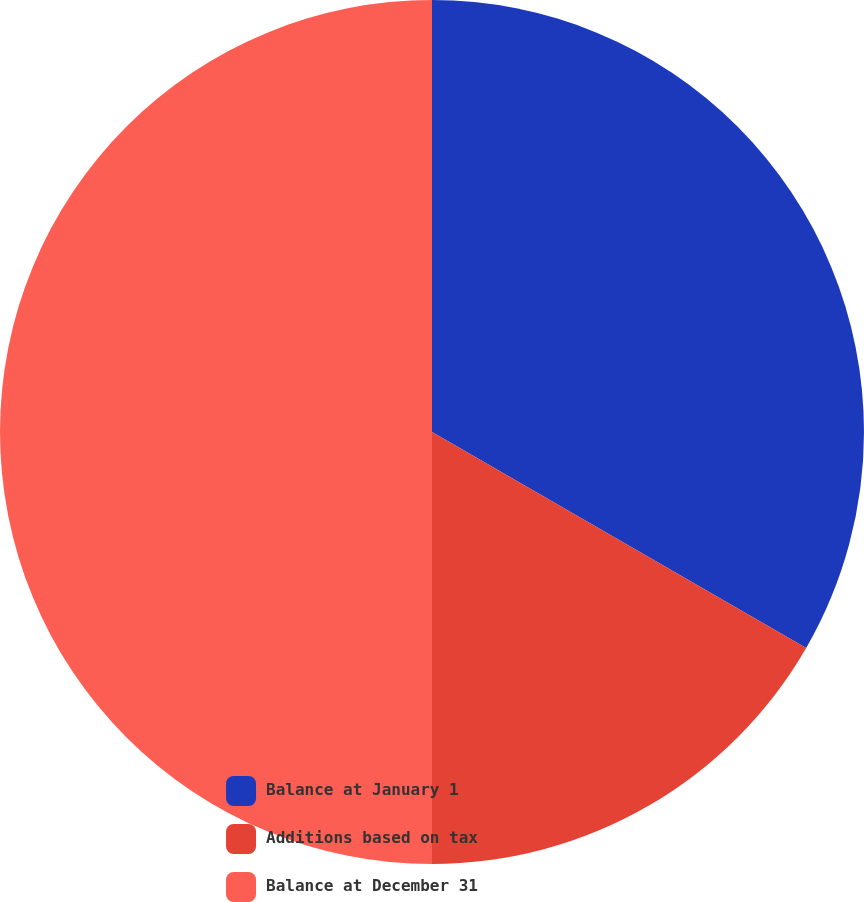Convert chart. <chart><loc_0><loc_0><loc_500><loc_500><pie_chart><fcel>Balance at January 1<fcel>Additions based on tax<fcel>Balance at December 31<nl><fcel>33.33%<fcel>16.67%<fcel>50.0%<nl></chart> 